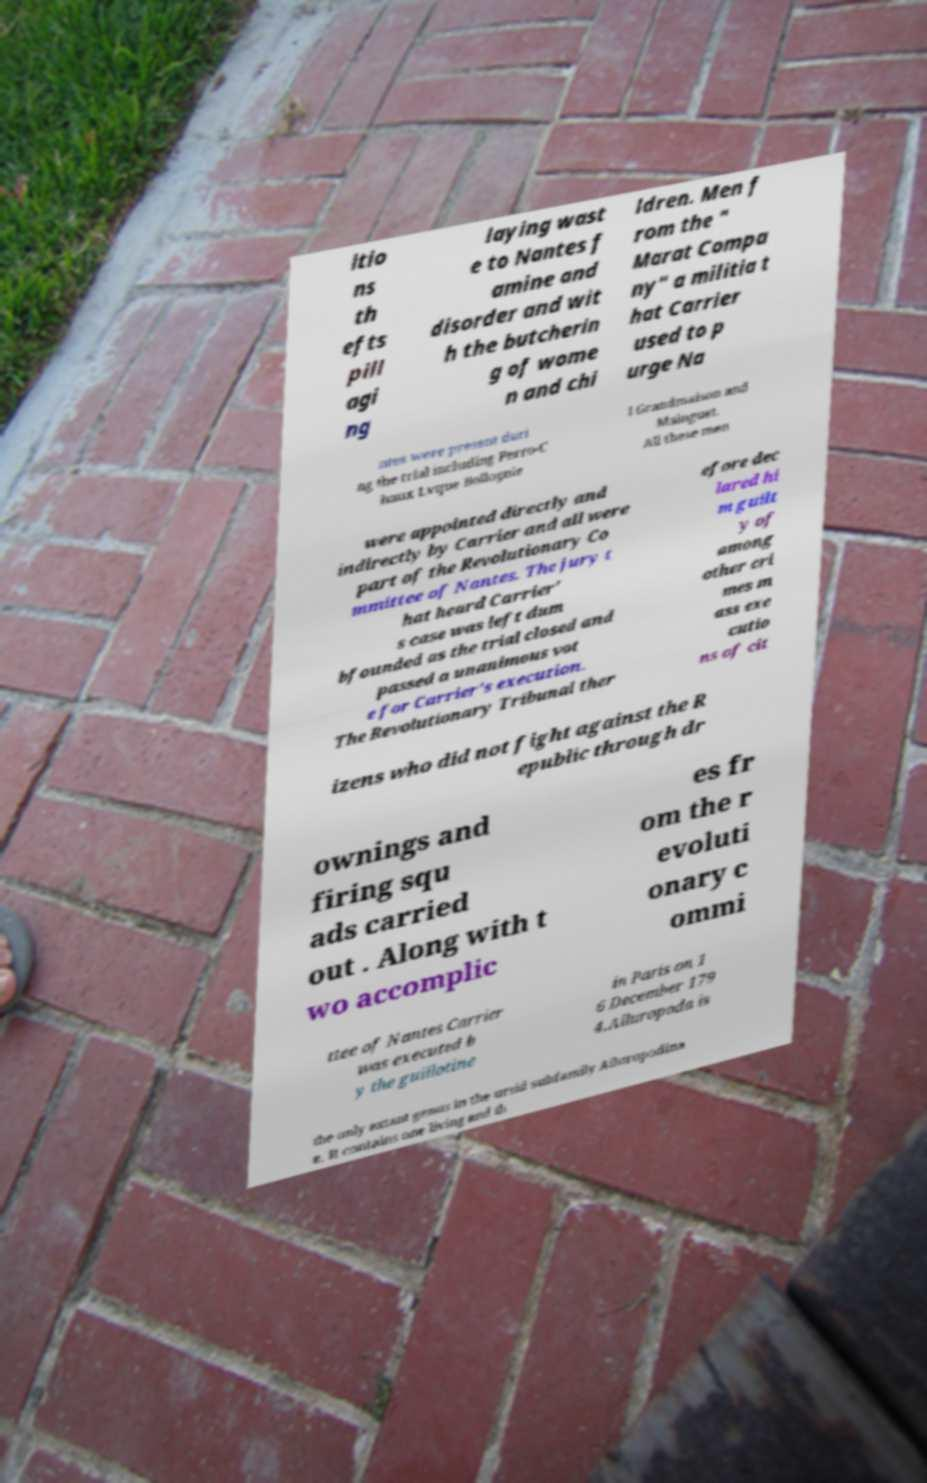Can you read and provide the text displayed in the image?This photo seems to have some interesting text. Can you extract and type it out for me? itio ns th efts pill agi ng laying wast e to Nantes f amine and disorder and wit h the butcherin g of wome n and chi ldren. Men f rom the " Marat Compa ny" a militia t hat Carrier used to p urge Na ntes were present duri ng the trial including Perro-C haux Lvque Bollognie l Grandmaison and Mainguet. All these men were appointed directly and indirectly by Carrier and all were part of the Revolutionary Co mmittee of Nantes. The jury t hat heard Carrier' s case was left dum bfounded as the trial closed and passed a unanimous vot e for Carrier's execution. The Revolutionary Tribunal ther efore dec lared hi m guilt y of among other cri mes m ass exe cutio ns of cit izens who did not fight against the R epublic through dr ownings and firing squ ads carried out . Along with t wo accomplic es fr om the r evoluti onary c ommi ttee of Nantes Carrier was executed b y the guillotine in Paris on 1 6 December 179 4.Ailuropoda is the only extant genus in the ursid subfamily Ailuropodina e. It contains one living and th 